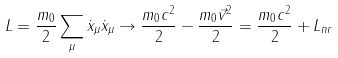Convert formula to latex. <formula><loc_0><loc_0><loc_500><loc_500>L = \frac { m _ { 0 } } { 2 } \sum _ { \mu } \dot { x } _ { \mu } \dot { x } _ { \mu } \rightarrow \frac { m _ { 0 } c ^ { 2 } } { 2 } - \frac { m _ { 0 } \vec { v } ^ { 2 } } { 2 } = \frac { m _ { 0 } c ^ { 2 } } { 2 } + L _ { n r }</formula> 